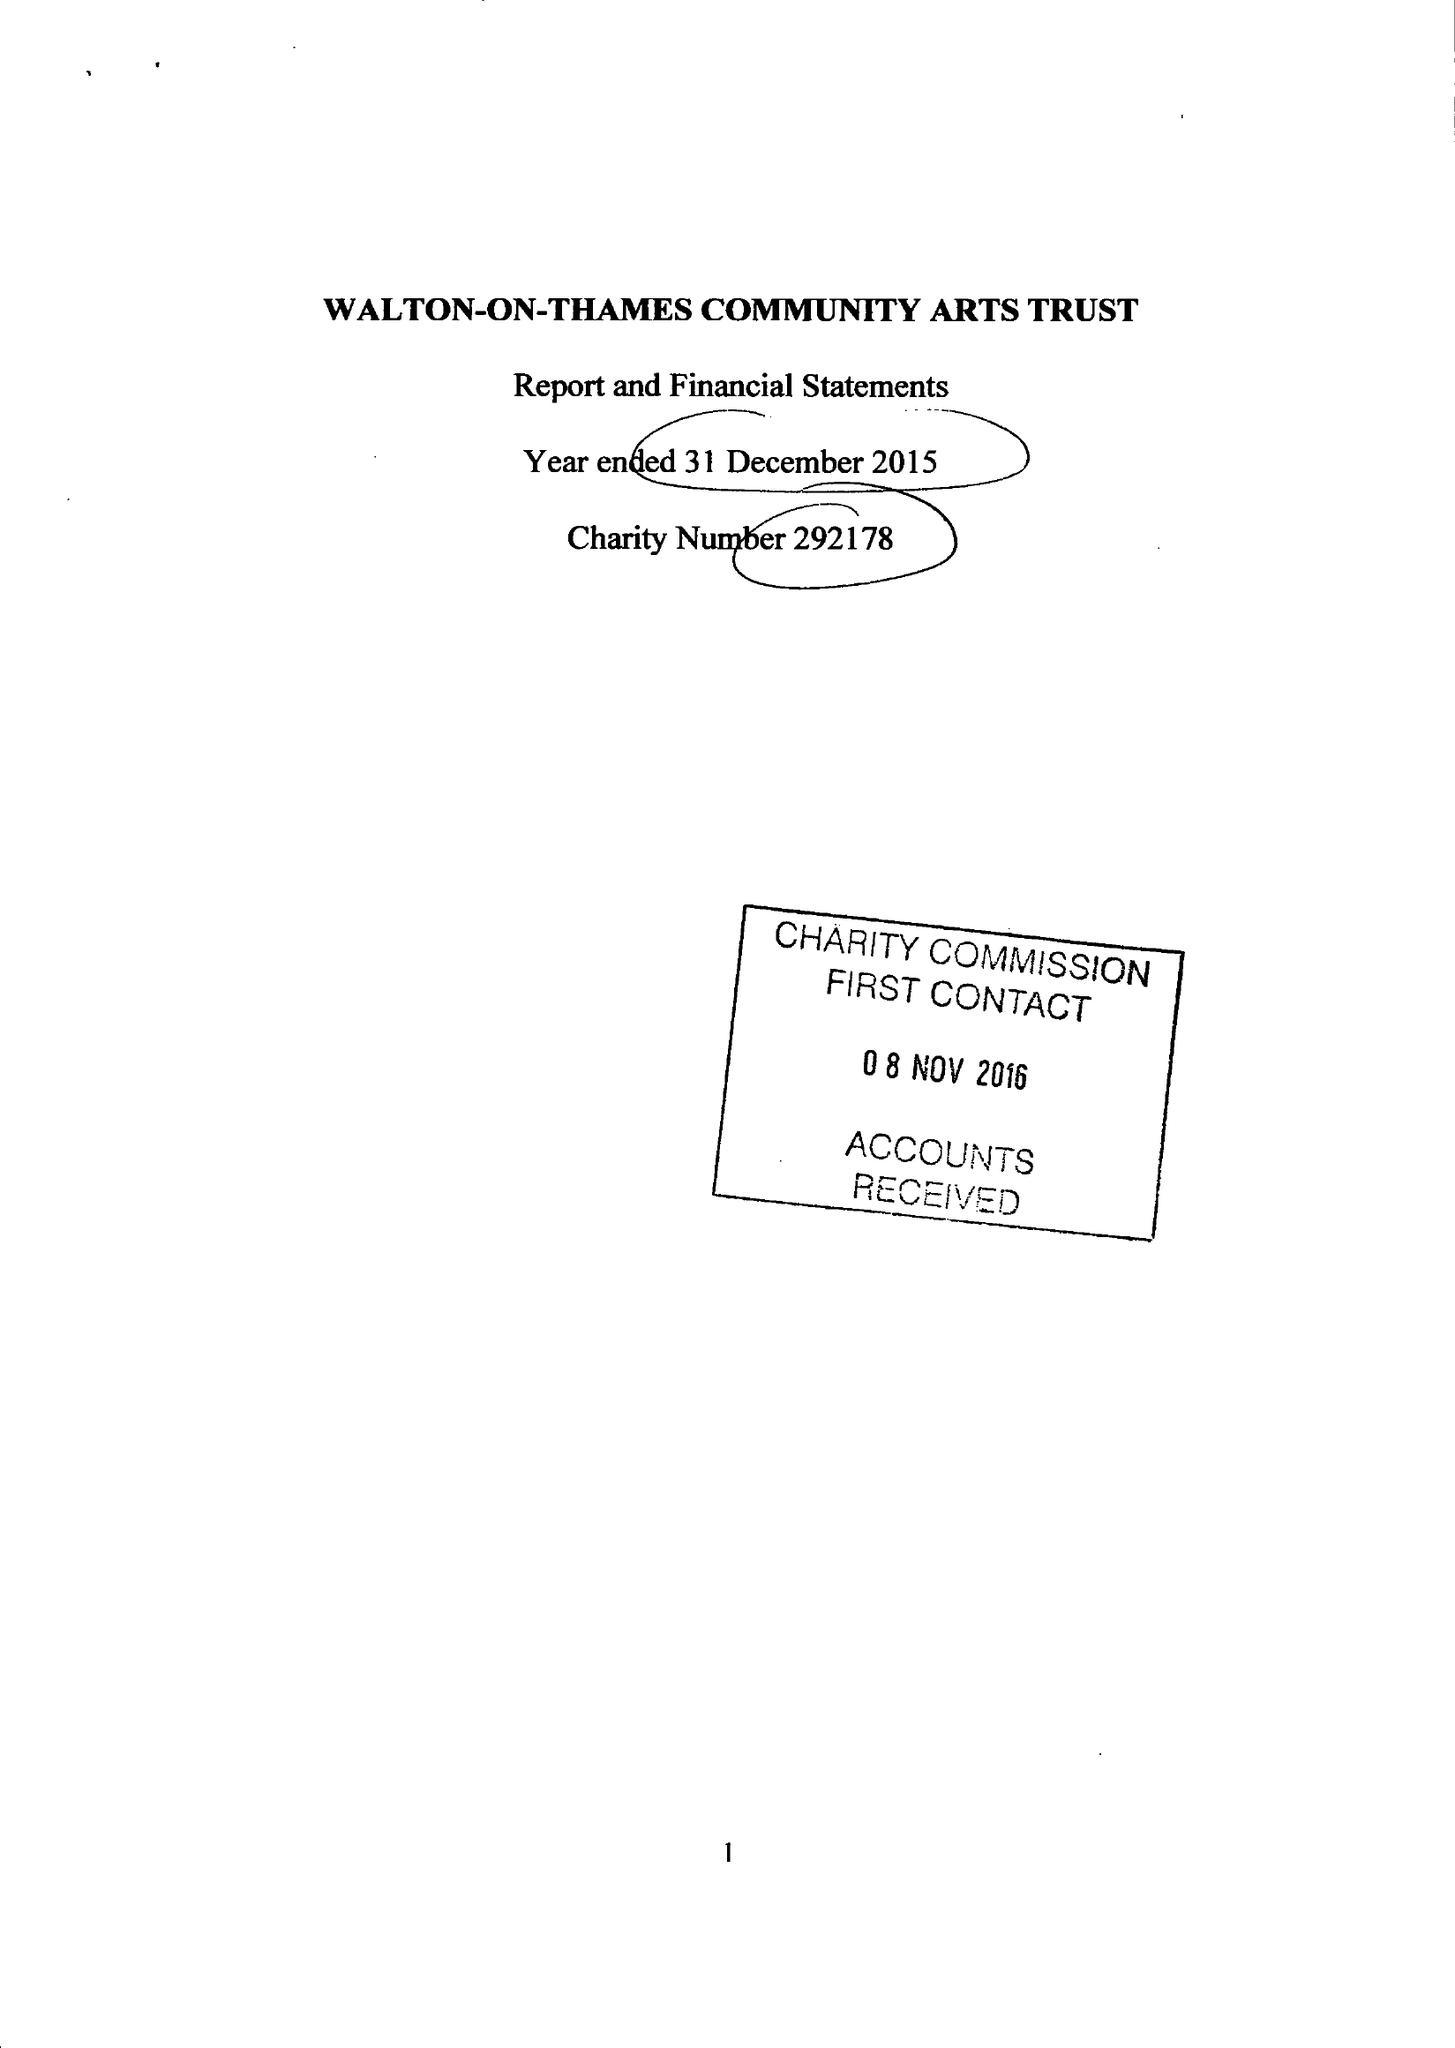What is the value for the address__street_line?
Answer the question using a single word or phrase. 29 RIVER MOUNT 